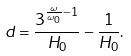<formula> <loc_0><loc_0><loc_500><loc_500>d = \frac { 3 ^ { \frac { \omega } { \omega _ { 0 } } - 1 } } { H _ { 0 } } - \frac { 1 } { H _ { 0 } } .</formula> 